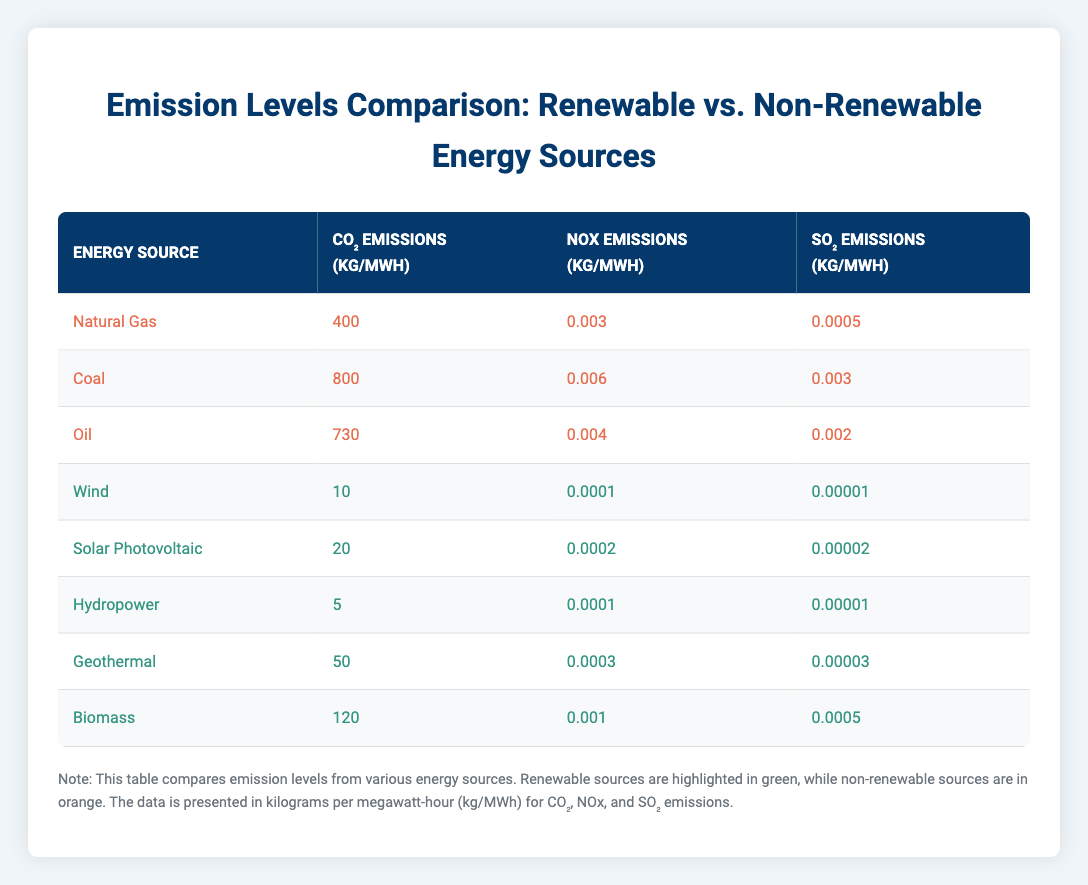What is the CO2 emission level for Hydropower? The table lists the CO2 emissions for each energy source. Looking at the row for Hydropower, it states that CO2 emissions are 5 kg per MWh.
Answer: 5 kg/MWh Which energy source emits the highest level of SO2? The table allows us to compare SO2 emissions from each energy source. Looking through the rows, Coal has the highest SO2 emissions at 0.003 kg per MWh.
Answer: Coal What is the difference in CO2 emissions between Natural Gas and Wind energy sources? To determine the difference, we subtract the CO2 emissions of Wind from Natural Gas. Natural Gas has 400 kg/MWh and Wind has 10 kg/MWh. Therefore, 400 - 10 = 390 kg/MWh.
Answer: 390 kg/MWh Are the NOx emissions from Biomass greater than those from Geothermal? By comparing the NOx emissions, Biomass has 0.001 kg/MWh while Geothermal has 0.0003 kg/MWh. Since 0.001 > 0.0003, the statement is true.
Answer: Yes What is the average CO2 emission level of renewable energy sources? The renewable sources listed are Wind, Solar Photovoltaic, Hydropower, Geothermal, and Biomass. Their CO2 emissions are 10, 20, 5, 50, and 120 kg/MWh. First, sum them up: 10 + 20 + 5 + 50 + 120 = 205. There are 5 data points, so the average is 205 / 5 = 41 kg/MWh.
Answer: 41 kg/MWh Which energy source shows the lowest NOx emission? By examining the NOx emissions in the table, Wind energy has the lowest NOx emissions at 0.0001 kg per MWh.
Answer: Wind How much greater are the CO2 emissions from Coal compared to Hydropower? The CO2 emissions for Coal are 800 kg/MWh, and for Hydropower, they are 5 kg/MWh. The difference is calculated by subtracting Hydropower emissions from Coal emissions: 800 - 5 = 795 kg/MWh.
Answer: 795 kg/MWh Is the total NOx emissions from the non-renewable sources greater than that from renewable sources? The total NOx emissions from non-renewable sources (Natural Gas: 0.003 + Coal: 0.006 + Oil: 0.004) sums to 0.013 kg/MWh. For renewables (Wind: 0.0001 + Solar: 0.0002 + Hydropower: 0.0001 + Geothermal: 0.0003 + Biomass: 0.001), the total is 0.0017 kg/MWh. Since 0.013 > 0.0017, the statement is true.
Answer: Yes What is the total SO2 emissions from all energy sources? To find the total, we sum the SO2 emissions for all listed sources: 0.0005 (Natural Gas) + 0.003 (Coal) + 0.002 (Oil) + 0.00001 (Wind) + 0.00002 (Solar) + 0.00001 (Hydropower) + 0.00003 (Geothermal) + 0.0005 (Biomass) = 0.00606 kg/MWh.
Answer: 0.00606 kg/MWh 